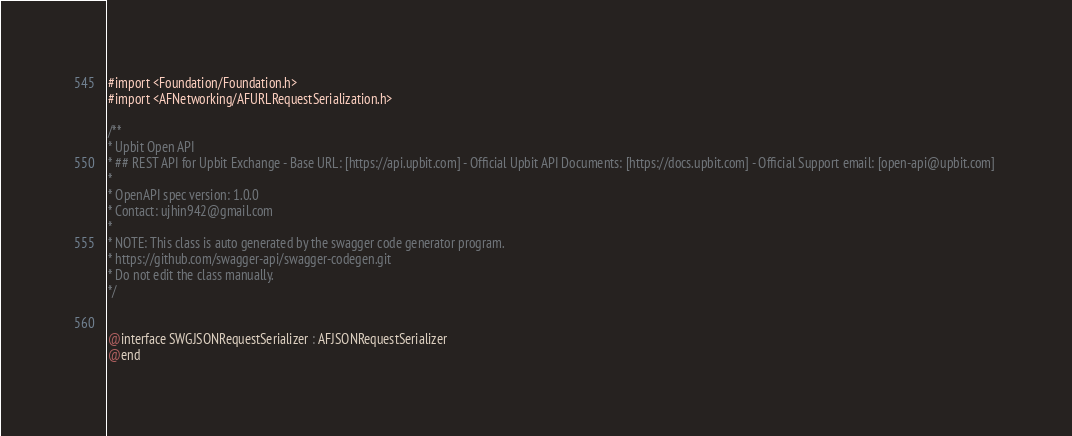<code> <loc_0><loc_0><loc_500><loc_500><_C_>#import <Foundation/Foundation.h>
#import <AFNetworking/AFURLRequestSerialization.h>

/**
* Upbit Open API
* ## REST API for Upbit Exchange - Base URL: [https://api.upbit.com] - Official Upbit API Documents: [https://docs.upbit.com] - Official Support email: [open-api@upbit.com] 
*
* OpenAPI spec version: 1.0.0
* Contact: ujhin942@gmail.com
*
* NOTE: This class is auto generated by the swagger code generator program.
* https://github.com/swagger-api/swagger-codegen.git
* Do not edit the class manually.
*/


@interface SWGJSONRequestSerializer : AFJSONRequestSerializer
@end
</code> 